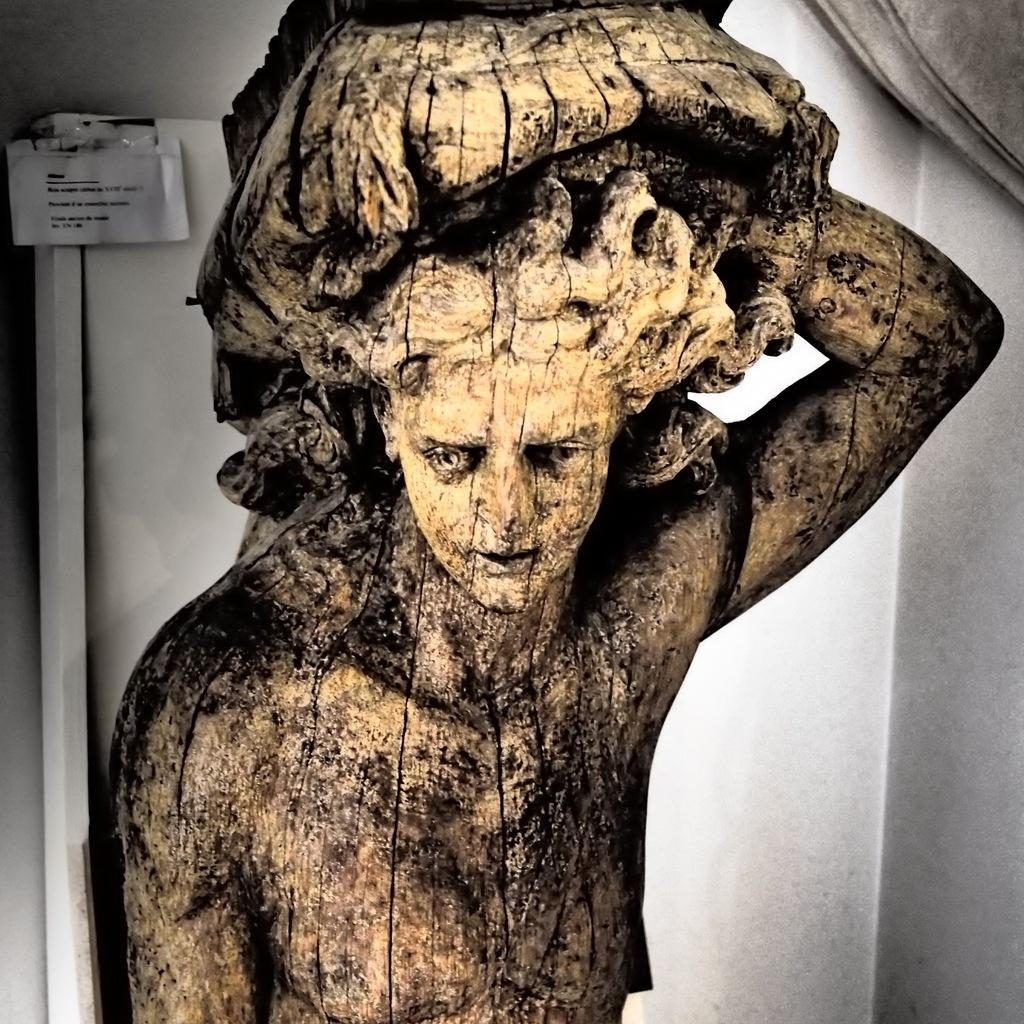What is the main subject of the image? There is a statue of a man in the image. What is the man in the statue doing? The man is lifting something in the statue. What color is the background of the image? The background of the image is white. What object can be seen in the image that is not part of the statue? There is a paper fixed to a stand in the image. What type of coat is the man wearing in the image? The man in the image is a statue and does not have a coat. What kind of toy can be seen in the hands of the man in the image? The man in the image is a statue and is not holding a toy. 